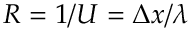<formula> <loc_0><loc_0><loc_500><loc_500>R = 1 / U = \Delta x / \lambda</formula> 